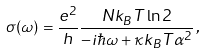<formula> <loc_0><loc_0><loc_500><loc_500>\sigma ( \omega ) = \frac { e ^ { 2 } } { h } \frac { N k _ { B } T \ln 2 } { - i \hbar { \omega } + \kappa k _ { B } T \alpha ^ { 2 } } \, ,</formula> 